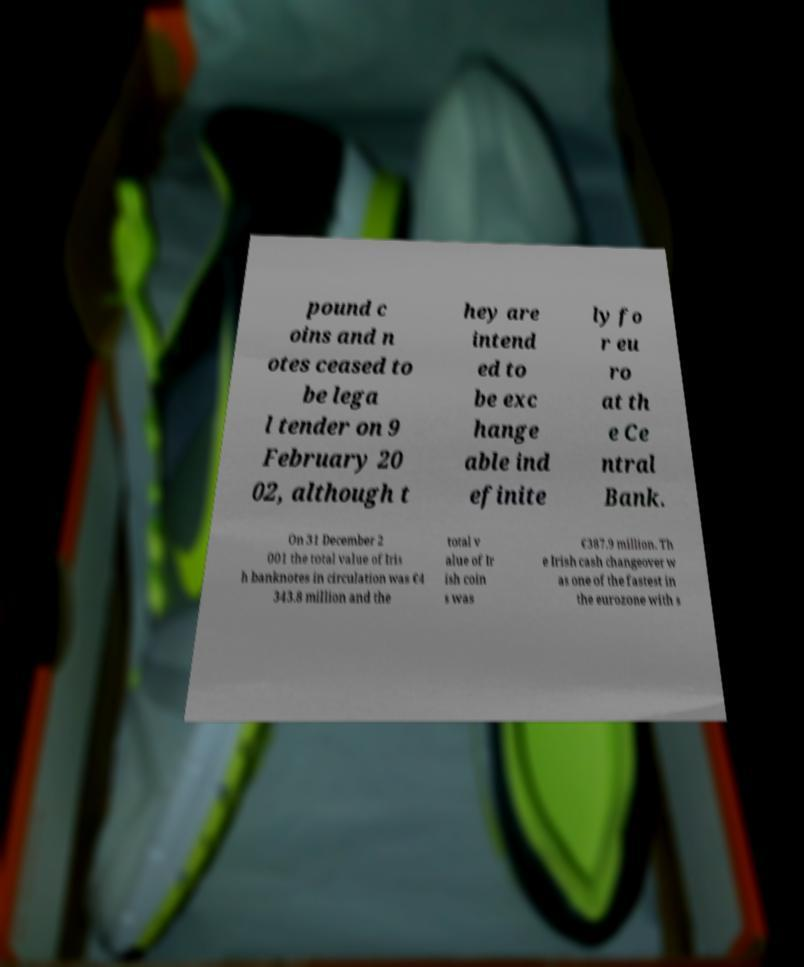What messages or text are displayed in this image? I need them in a readable, typed format. pound c oins and n otes ceased to be lega l tender on 9 February 20 02, although t hey are intend ed to be exc hange able ind efinite ly fo r eu ro at th e Ce ntral Bank. On 31 December 2 001 the total value of Iris h banknotes in circulation was €4 343.8 million and the total v alue of Ir ish coin s was €387.9 million. Th e Irish cash changeover w as one of the fastest in the eurozone with s 